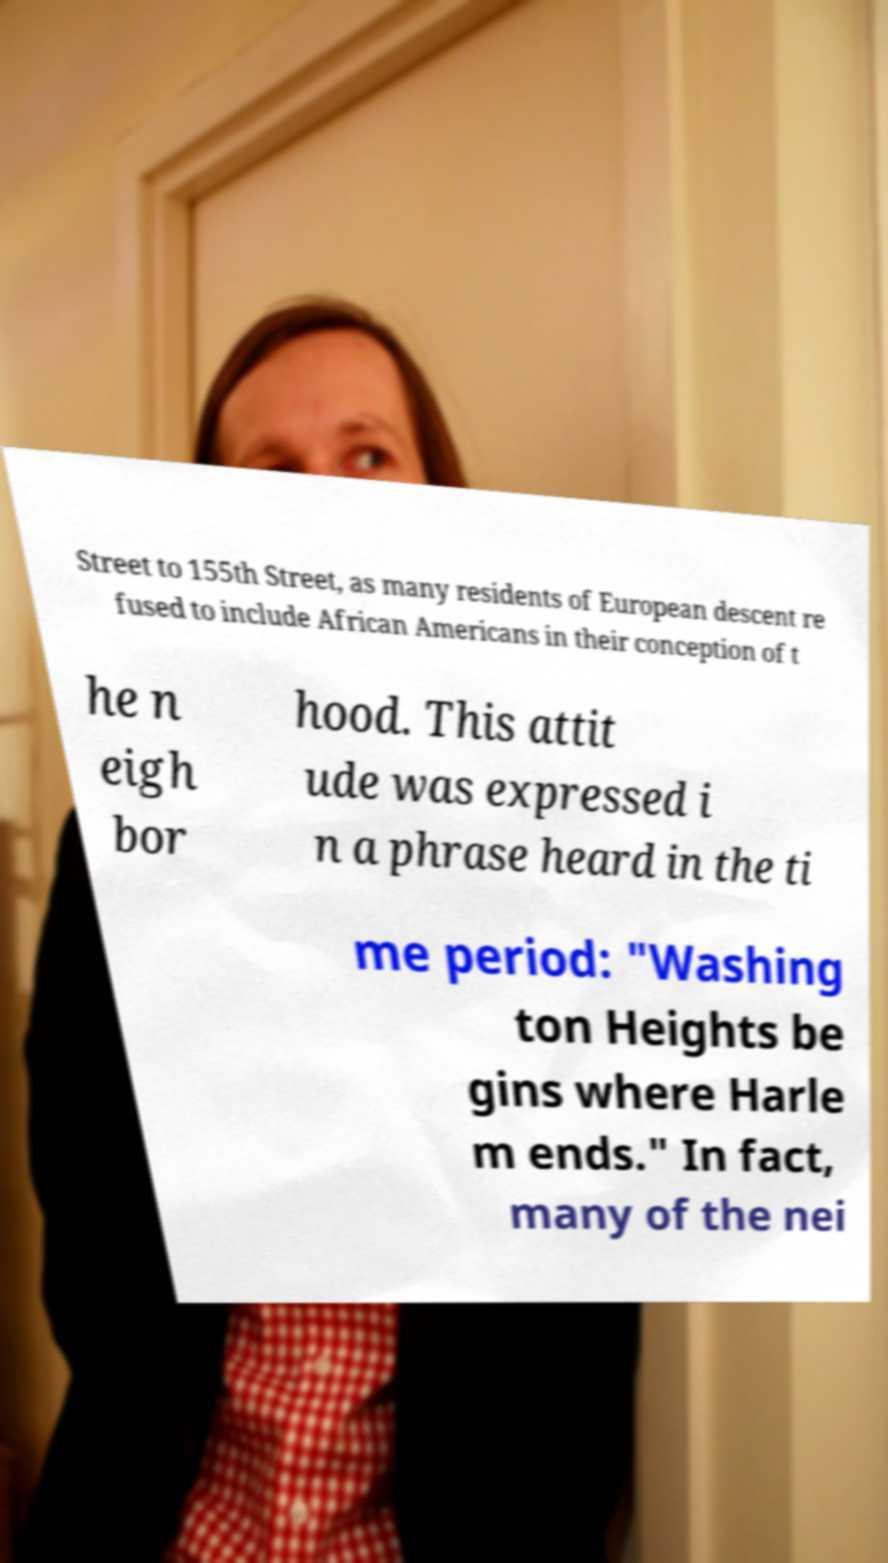What messages or text are displayed in this image? I need them in a readable, typed format. Street to 155th Street, as many residents of European descent re fused to include African Americans in their conception of t he n eigh bor hood. This attit ude was expressed i n a phrase heard in the ti me period: "Washing ton Heights be gins where Harle m ends." In fact, many of the nei 